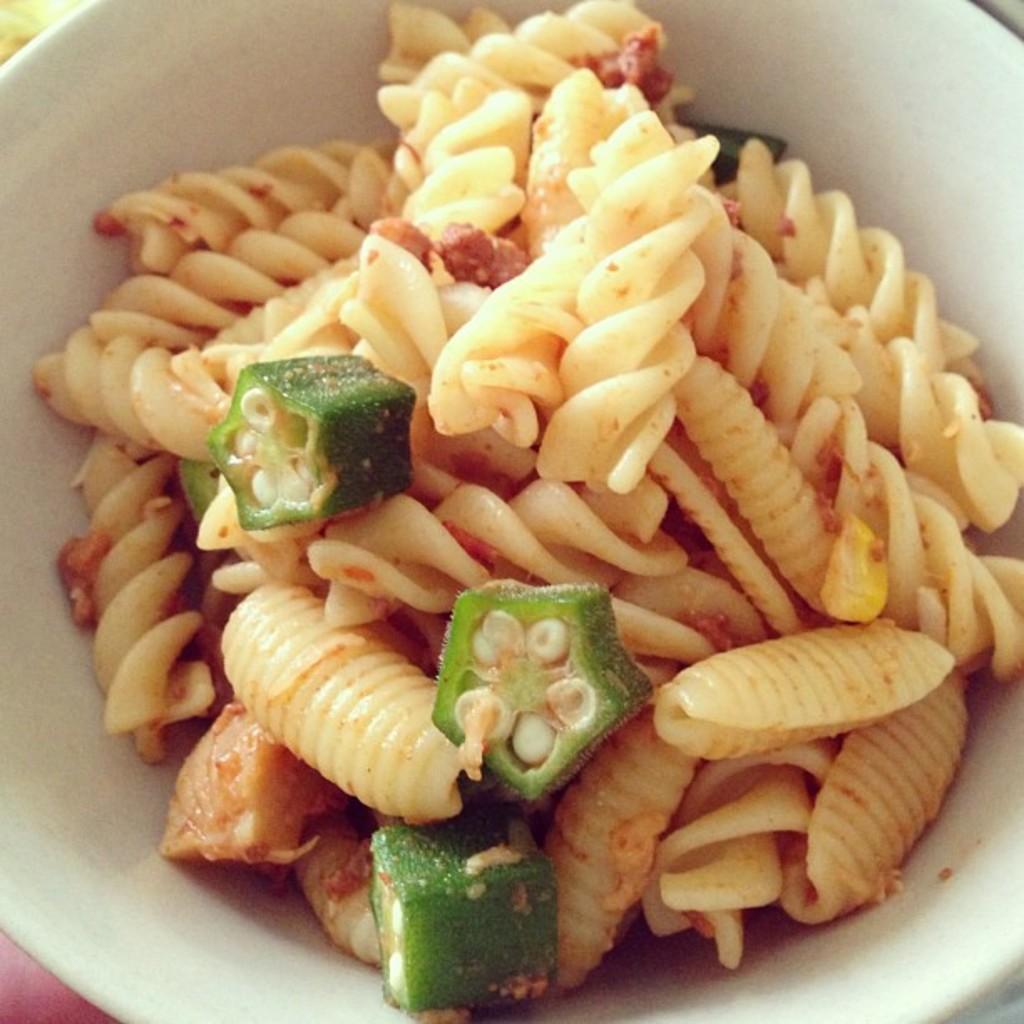Describe this image in one or two sentences. In the image there is macaroni,okra in a bowl. 